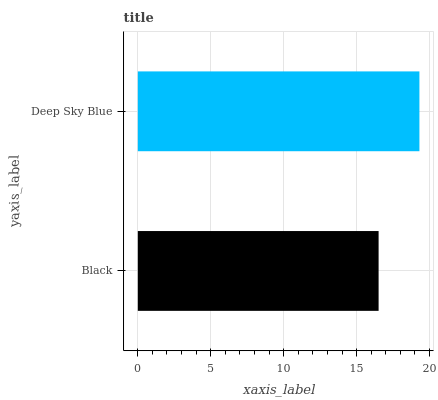Is Black the minimum?
Answer yes or no. Yes. Is Deep Sky Blue the maximum?
Answer yes or no. Yes. Is Deep Sky Blue the minimum?
Answer yes or no. No. Is Deep Sky Blue greater than Black?
Answer yes or no. Yes. Is Black less than Deep Sky Blue?
Answer yes or no. Yes. Is Black greater than Deep Sky Blue?
Answer yes or no. No. Is Deep Sky Blue less than Black?
Answer yes or no. No. Is Deep Sky Blue the high median?
Answer yes or no. Yes. Is Black the low median?
Answer yes or no. Yes. Is Black the high median?
Answer yes or no. No. Is Deep Sky Blue the low median?
Answer yes or no. No. 